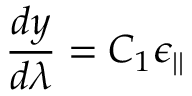Convert formula to latex. <formula><loc_0><loc_0><loc_500><loc_500>\frac { d y } { d \lambda } = C _ { 1 } \epsilon _ { | | }</formula> 